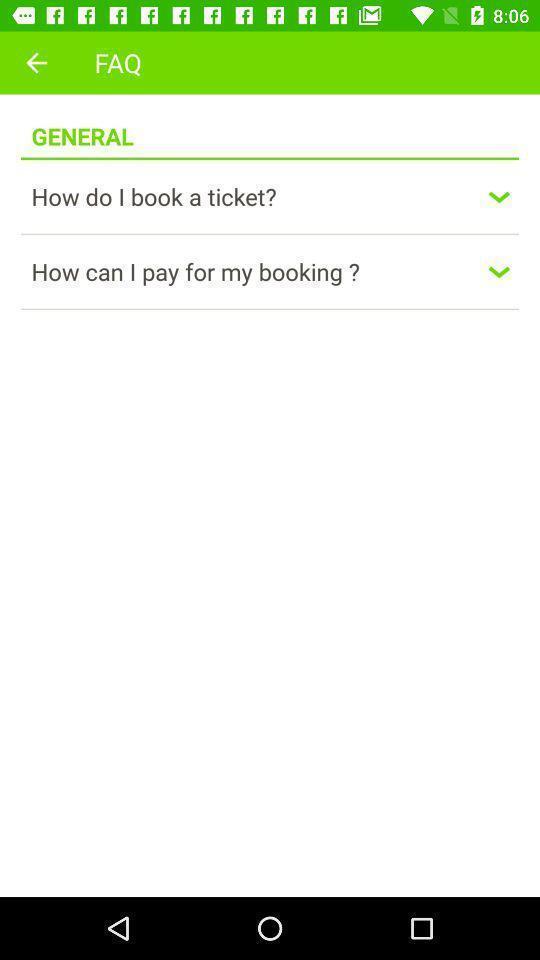Provide a detailed account of this screenshot. Screen is showing faq. 